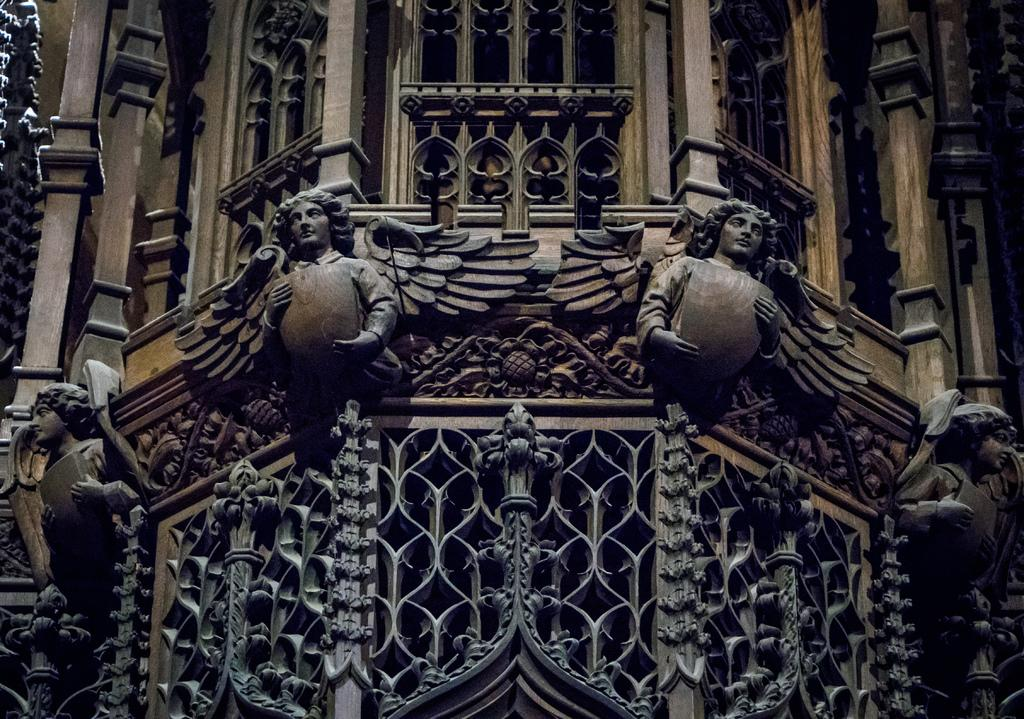What is the main subject of the image? The main subject of the image is a building. What can be seen on the building? There are sculptures on the wall of the building. What is located at the bottom of the image? There are design grills at the bottom of the image. How many fingers can be seen on the baseball player in the image? There is no baseball player or fingers present in the image; it features a building with sculptures on the wall and design grills at the bottom. 